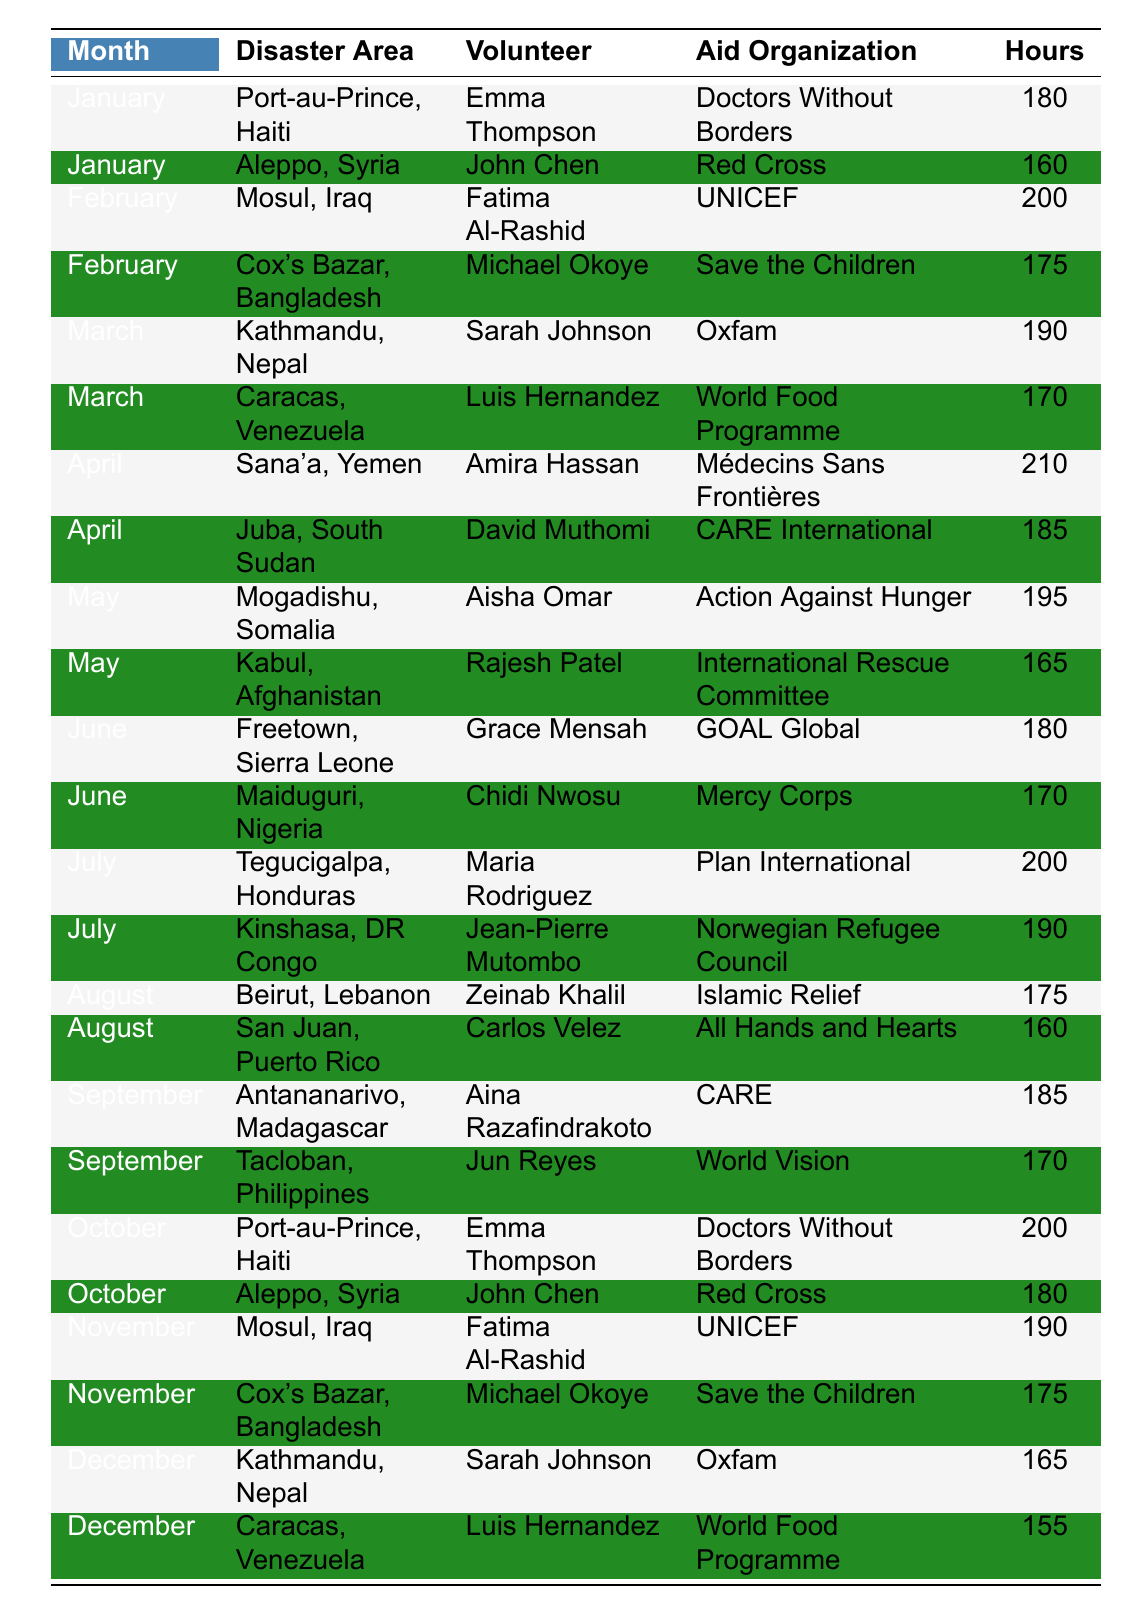What is the total number of volunteer hours logged in April? In April, two entries are recorded: 210 hours (Sana'a, Yemen) and 185 hours (Juba, South Sudan). Adding these gives a total of 210 + 185 = 395 hours.
Answer: 395 Who logged the most hours in October and how many hours? In October, two volunteers are listed: Emma Thompson with 200 hours (Port-au-Prince, Haiti) and John Chen with 180 hours (Aleppo, Syria). The most hours logged is 200 by Emma Thompson.
Answer: 200 by Emma Thompson Which month had the highest total logged hours across all disaster areas? Calculate total hours for each month: January (180 + 160 = 340), February (200 + 175 = 375), March (190 + 170 = 360), April (210 + 185 = 395), May (195 + 165 = 360), June (180 + 170 = 350), July (200 + 190 = 390), August (175 + 160 = 335), September (185 + 170 = 355), October (200 + 180 = 380), November (190 + 175 = 365), December (165 + 155 = 320). The highest total is 395 in April.
Answer: April Is there a month where at least one volunteer logged over 200 hours? Check each month's logged hours for values over 200. April (210) has a volunteer with logged hours greater than 200. So, the answer is yes.
Answer: Yes How many total hours did Sarah Johnson log throughout the year? Sarah Johnson appears twice: in March (190 hours) and December (165 hours). Adding these gives 190 + 165 = 355 hours logged by Sarah Johnson.
Answer: 355 In which disaster area did Aisha Omar volunteer and how many hours did she log? Aisha Omar volunteered in Mogadishu, Somalia, and logged 195 hours.
Answer: Mogadishu, Somalia, 195 hours What is the average number of hours logged per volunteer in January? In January, there are two volunteers: Emma Thompson (180 hours) and John Chen (160 hours). The average is (180 + 160) / 2 = 170 hours.
Answer: 170 Which aid organization has the highest total logged hours? Calculate total hours for each organization: Doctors Without Borders (380), Red Cross (340), UNICEF (390), Save the Children (350), Oxfam (355), Médecins Sans Frontières (210), CARE International (185), Action Against Hunger (195), International Rescue Committee (165), GOAL Global (180), Mercy Corps (170), Plan International (200), Norwegian Refugee Council (190), Islamic Relief (175), All Hands and Hearts (160), CARE (185), World Vision (170), World Food Programme (315). The highest total is by Doctors Without Borders with 380 hours.
Answer: Doctors Without Borders How many unique disaster areas were worked on across the year? Count the number of unique disaster areas from the data: Port-au-Prince, Aleppo, Mosul, Cox's Bazar, Kathmandu, Caracas, Sana'a, Juba, Mogadishu, Kabul, Freetown, Maiduguri, Tegucigalpa, Kinshasa, Beirut, San Juan, Antananarivo, Tacloban. There are 17 unique areas.
Answer: 17 Was there a volunteer who logged the same number of hours in consecutive months? Review the logged hours month by month: Emma Thompson (January 180, October 200), John Chen (January 160, October 180), Fatima Al-Rashid (February 200, November 190), Michael Okoye (February 175, November 175), etc. No one logged the same in consecutive months.
Answer: No 